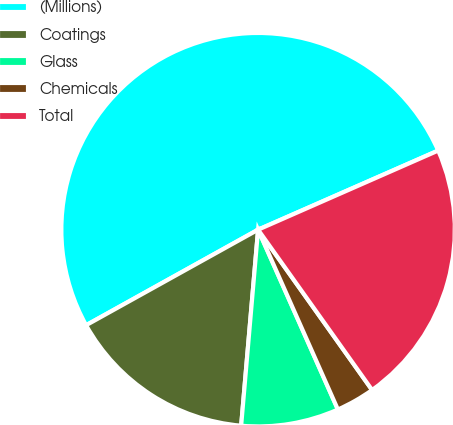<chart> <loc_0><loc_0><loc_500><loc_500><pie_chart><fcel>(Millions)<fcel>Coatings<fcel>Glass<fcel>Chemicals<fcel>Total<nl><fcel>51.48%<fcel>15.56%<fcel>8.02%<fcel>3.19%<fcel>21.75%<nl></chart> 